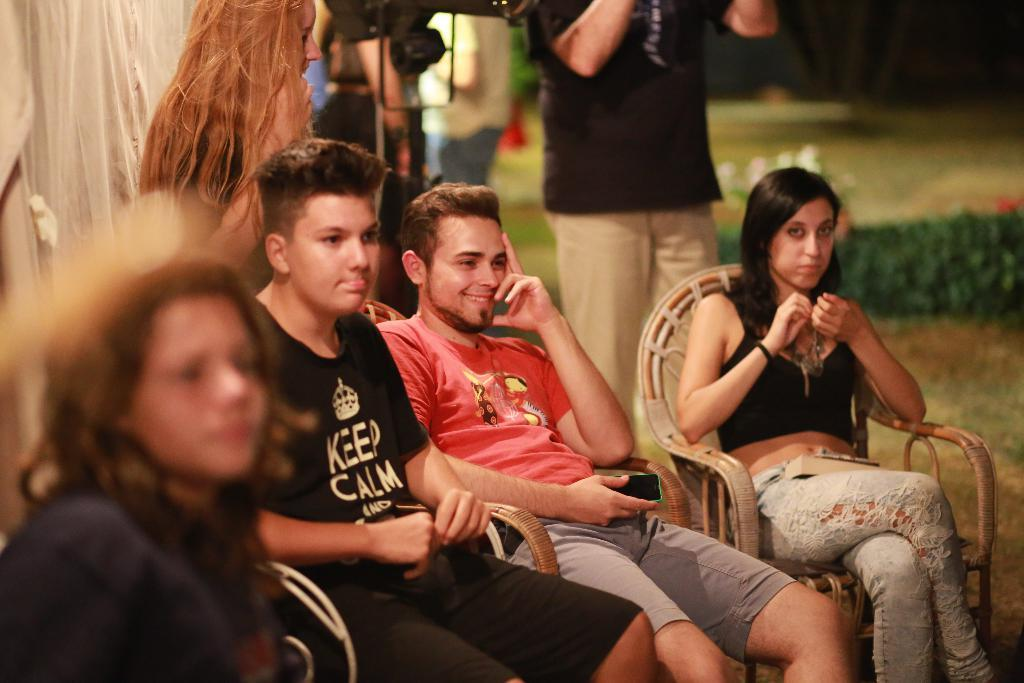How many men and women are present in the image? There are two men and two women in the image. What are the men and women doing in the image? The men and women are sitting on chairs. Can you describe the background of the image? There are people standing and plants in the background of the image, as well as grass. What type of pet can be seen playing with the grass in the image? There is no pet present in the image, and therefore no such activity can be observed. 